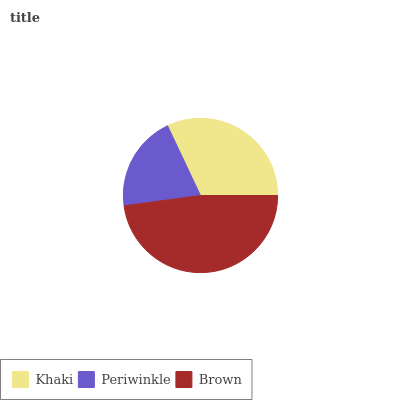Is Periwinkle the minimum?
Answer yes or no. Yes. Is Brown the maximum?
Answer yes or no. Yes. Is Brown the minimum?
Answer yes or no. No. Is Periwinkle the maximum?
Answer yes or no. No. Is Brown greater than Periwinkle?
Answer yes or no. Yes. Is Periwinkle less than Brown?
Answer yes or no. Yes. Is Periwinkle greater than Brown?
Answer yes or no. No. Is Brown less than Periwinkle?
Answer yes or no. No. Is Khaki the high median?
Answer yes or no. Yes. Is Khaki the low median?
Answer yes or no. Yes. Is Brown the high median?
Answer yes or no. No. Is Brown the low median?
Answer yes or no. No. 